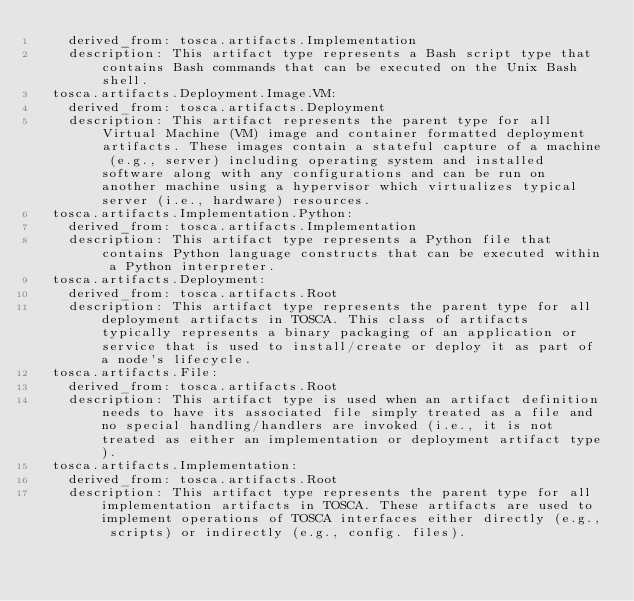<code> <loc_0><loc_0><loc_500><loc_500><_YAML_>    derived_from: tosca.artifacts.Implementation
    description: This artifact type represents a Bash script type that contains Bash commands that can be executed on the Unix Bash shell.
  tosca.artifacts.Deployment.Image.VM:
    derived_from: tosca.artifacts.Deployment
    description: This artifact represents the parent type for all Virtual Machine (VM) image and container formatted deployment artifacts. These images contain a stateful capture of a machine (e.g., server) including operating system and installed software along with any configurations and can be run on another machine using a hypervisor which virtualizes typical server (i.e., hardware) resources.
  tosca.artifacts.Implementation.Python:
    derived_from: tosca.artifacts.Implementation
    description: This artifact type represents a Python file that contains Python language constructs that can be executed within a Python interpreter.
  tosca.artifacts.Deployment:
    derived_from: tosca.artifacts.Root
    description: This artifact type represents the parent type for all deployment artifacts in TOSCA. This class of artifacts typically represents a binary packaging of an application or service that is used to install/create or deploy it as part of a node's lifecycle.
  tosca.artifacts.File:
    derived_from: tosca.artifacts.Root
    description: This artifact type is used when an artifact definition needs to have its associated file simply treated as a file and no special handling/handlers are invoked (i.e., it is not treated as either an implementation or deployment artifact type).
  tosca.artifacts.Implementation:
    derived_from: tosca.artifacts.Root
    description: This artifact type represents the parent type for all implementation artifacts in TOSCA. These artifacts are used to implement operations of TOSCA interfaces either directly (e.g., scripts) or indirectly (e.g., config. files).
</code> 